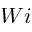<formula> <loc_0><loc_0><loc_500><loc_500>W i</formula> 